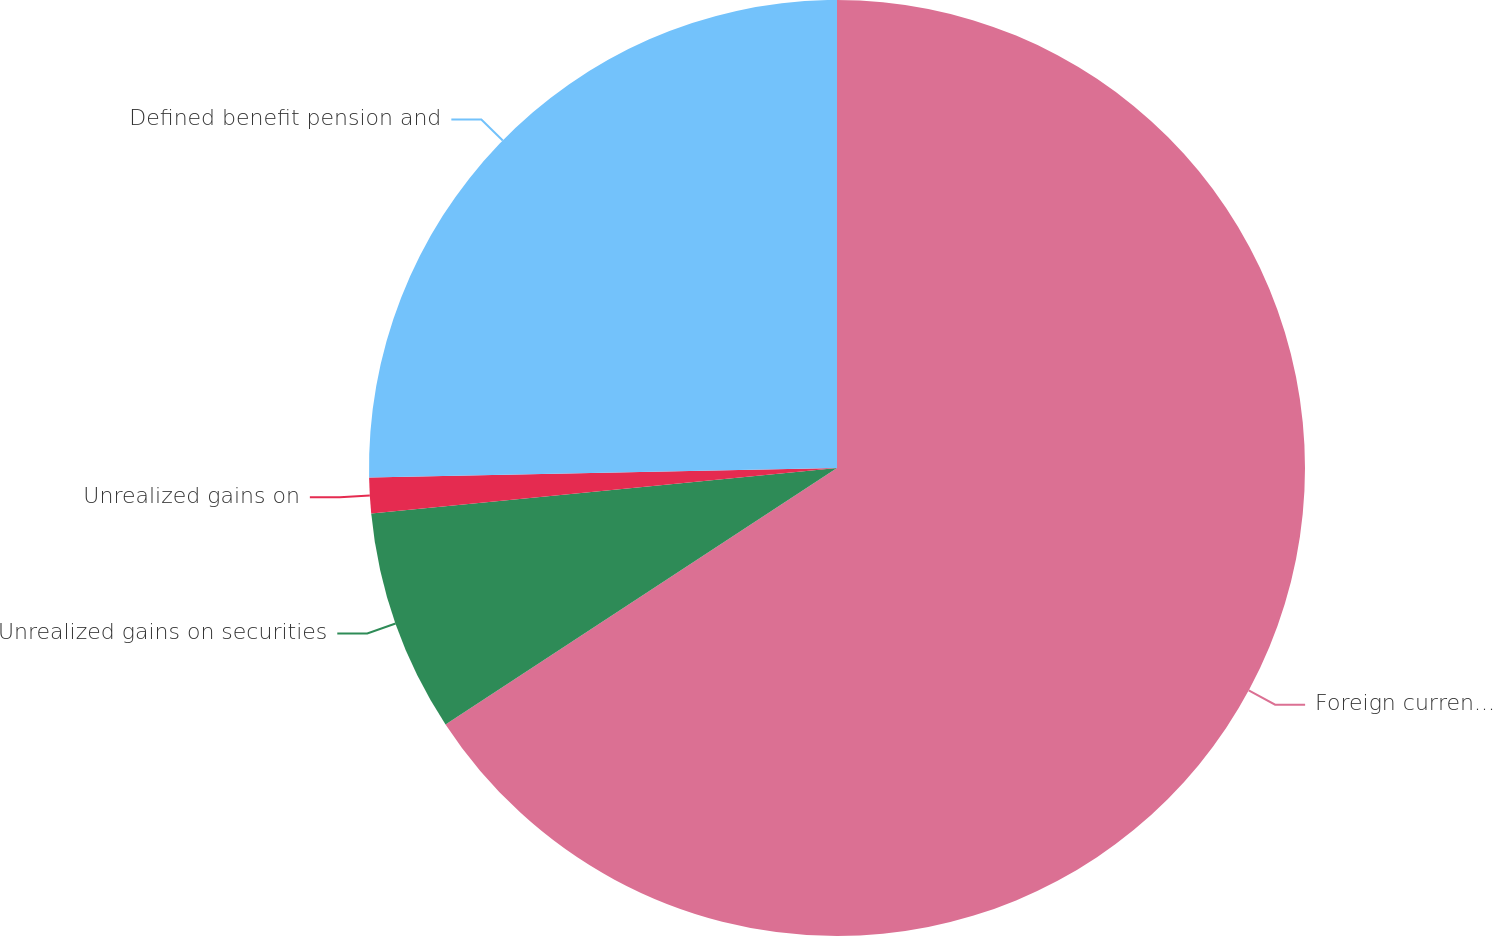Convert chart. <chart><loc_0><loc_0><loc_500><loc_500><pie_chart><fcel>Foreign currency translation<fcel>Unrealized gains on securities<fcel>Unrealized gains on<fcel>Defined benefit pension and<nl><fcel>65.77%<fcel>7.68%<fcel>1.23%<fcel>25.32%<nl></chart> 